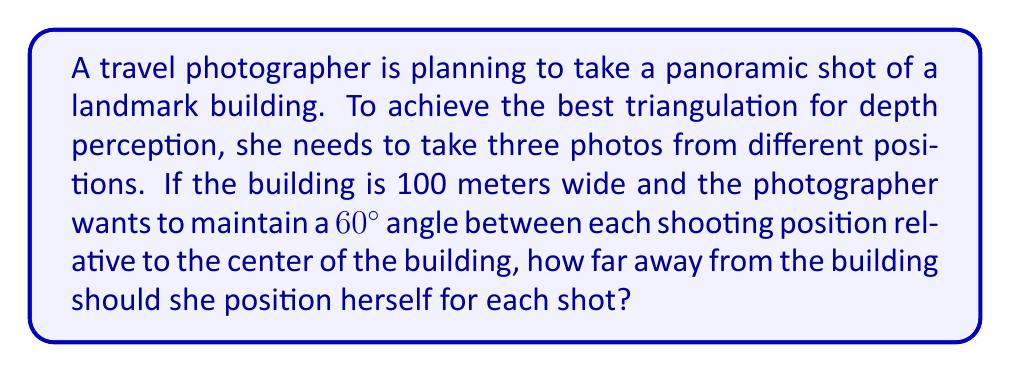Can you solve this math problem? Let's approach this step-by-step:

1) First, we need to visualize the problem. The photographer and the building form an isosceles triangle, where:
   - The base of the triangle is the width of the building (100 m)
   - The two equal sides are the distance from the photographer to each end of the building
   - The angle at the top of the triangle (where the photographer is) is 60°

2) We can split this isosceles triangle into two right triangles. Let's focus on one of these right triangles:
   - The base is half the width of the building: $50$ m
   - The angle at the photographer's position is 30° (half of 60°)
   - We need to find the hypotenuse, which is the distance from the photographer to the building

3) In a right triangle, we can use the tangent function:

   $$\tan 30° = \frac{\text{opposite}}{\text{adjacent}} = \frac{50}{\text{distance}}$$

4) We know that $\tan 30° = \frac{1}{\sqrt{3}}$, so:

   $$\frac{1}{\sqrt{3}} = \frac{50}{\text{distance}}$$

5) Cross multiply:

   $$\text{distance} = 50\sqrt{3}$$

6) Calculate the result:

   $$\text{distance} \approx 86.60 \text{ meters}$$

Therefore, the photographer should position herself approximately 86.60 meters away from the building for each shot.
Answer: $86.60$ meters 